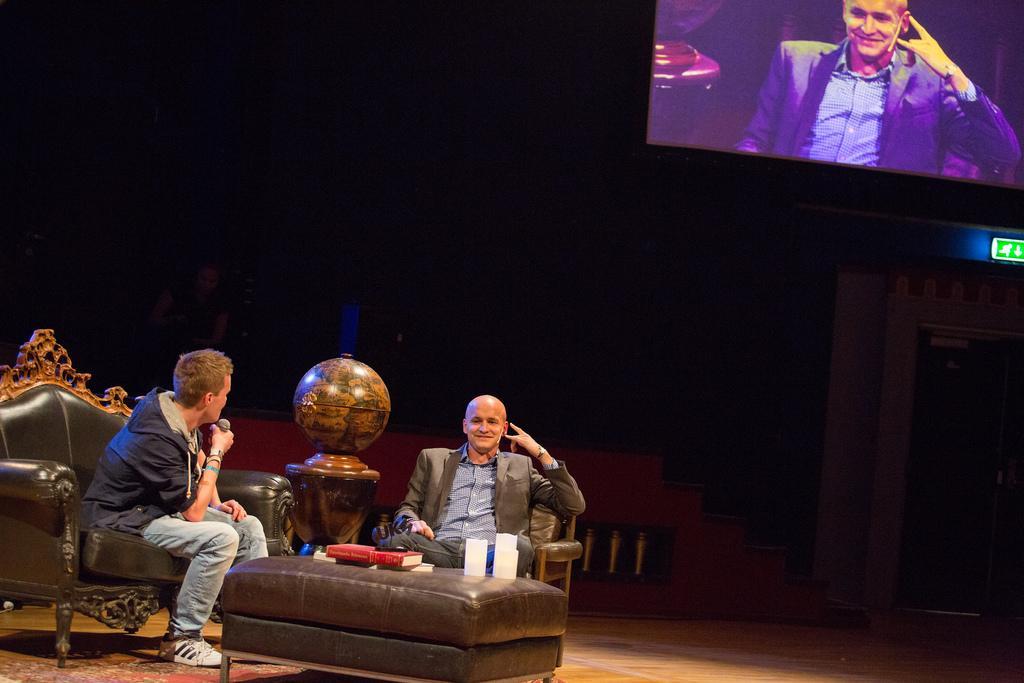Could you give a brief overview of what you see in this image? In this image we can see some people, couches, table, globe and other objects. In the background of the image there is a wall, screen, steps and other objects. At the bottom of the image there is the floor. 